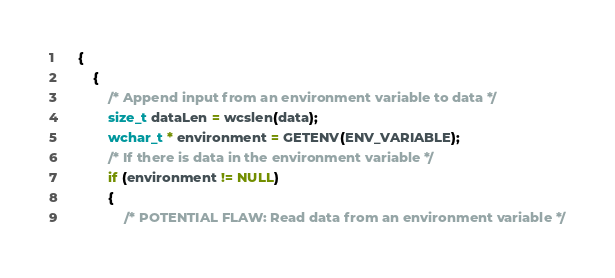<code> <loc_0><loc_0><loc_500><loc_500><_C++_>    {
        {
            /* Append input from an environment variable to data */
            size_t dataLen = wcslen(data);
            wchar_t * environment = GETENV(ENV_VARIABLE);
            /* If there is data in the environment variable */
            if (environment != NULL)
            {
                /* POTENTIAL FLAW: Read data from an environment variable */</code> 